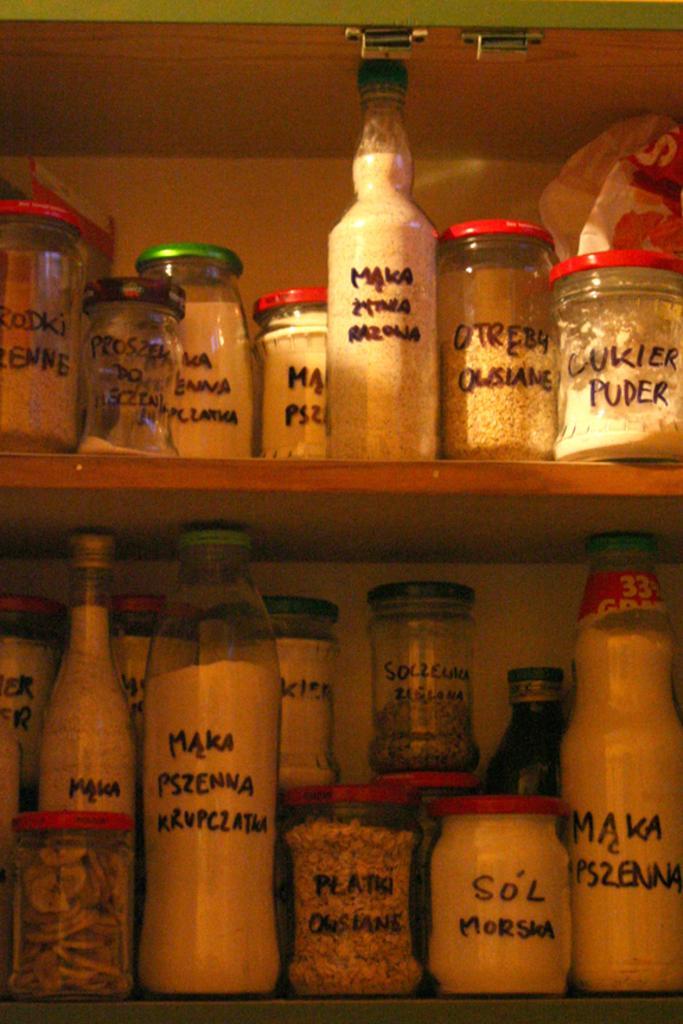Please provide a concise description of this image. This picture is mainly highlighted with jar and bottle containers and we can see different types of spices in it and they are in a rack. 